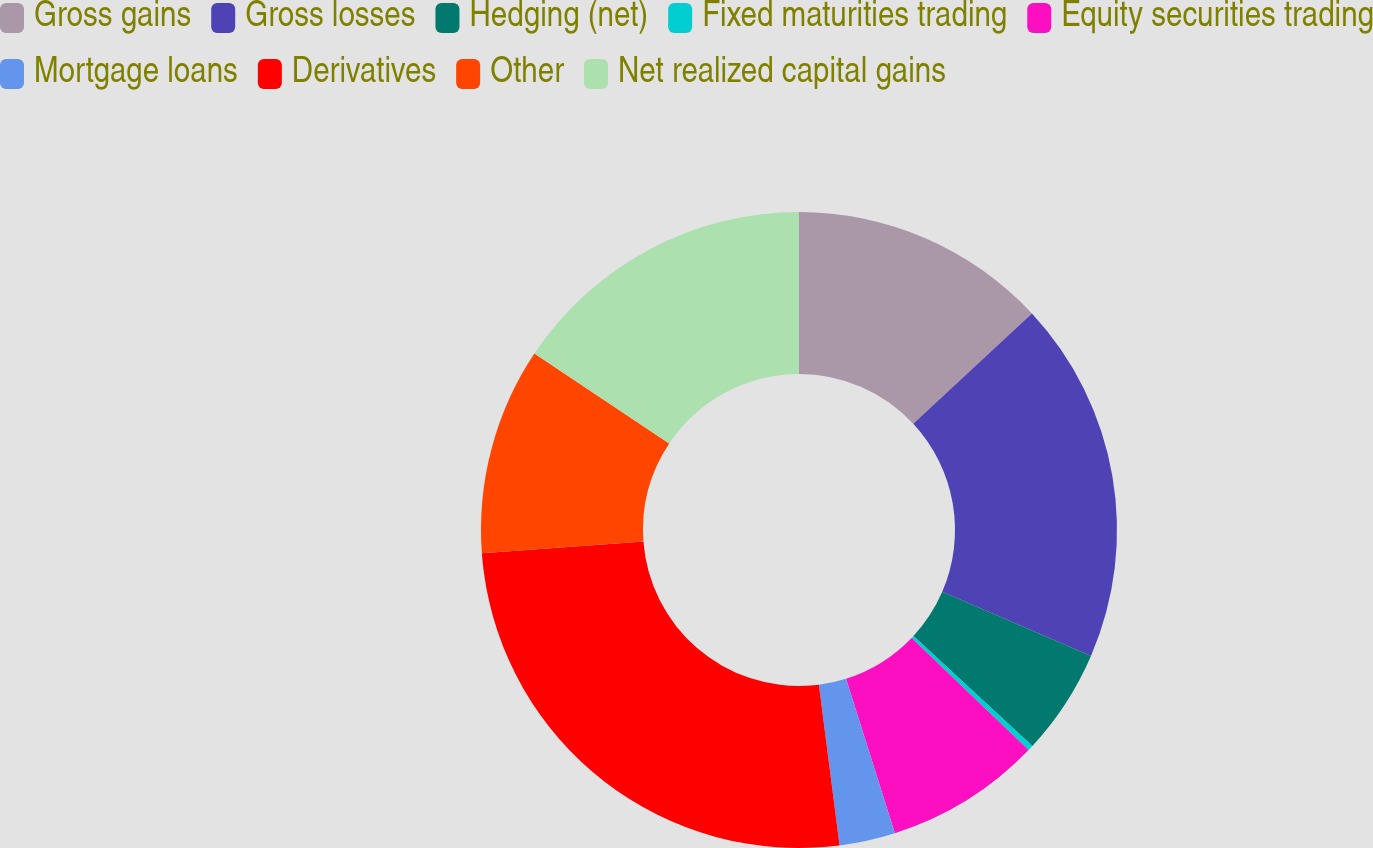<chart> <loc_0><loc_0><loc_500><loc_500><pie_chart><fcel>Gross gains<fcel>Gross losses<fcel>Hedging (net)<fcel>Fixed maturities trading<fcel>Equity securities trading<fcel>Mortgage loans<fcel>Derivatives<fcel>Other<fcel>Net realized capital gains<nl><fcel>13.08%<fcel>18.4%<fcel>5.4%<fcel>0.28%<fcel>7.96%<fcel>2.84%<fcel>25.87%<fcel>10.52%<fcel>15.64%<nl></chart> 